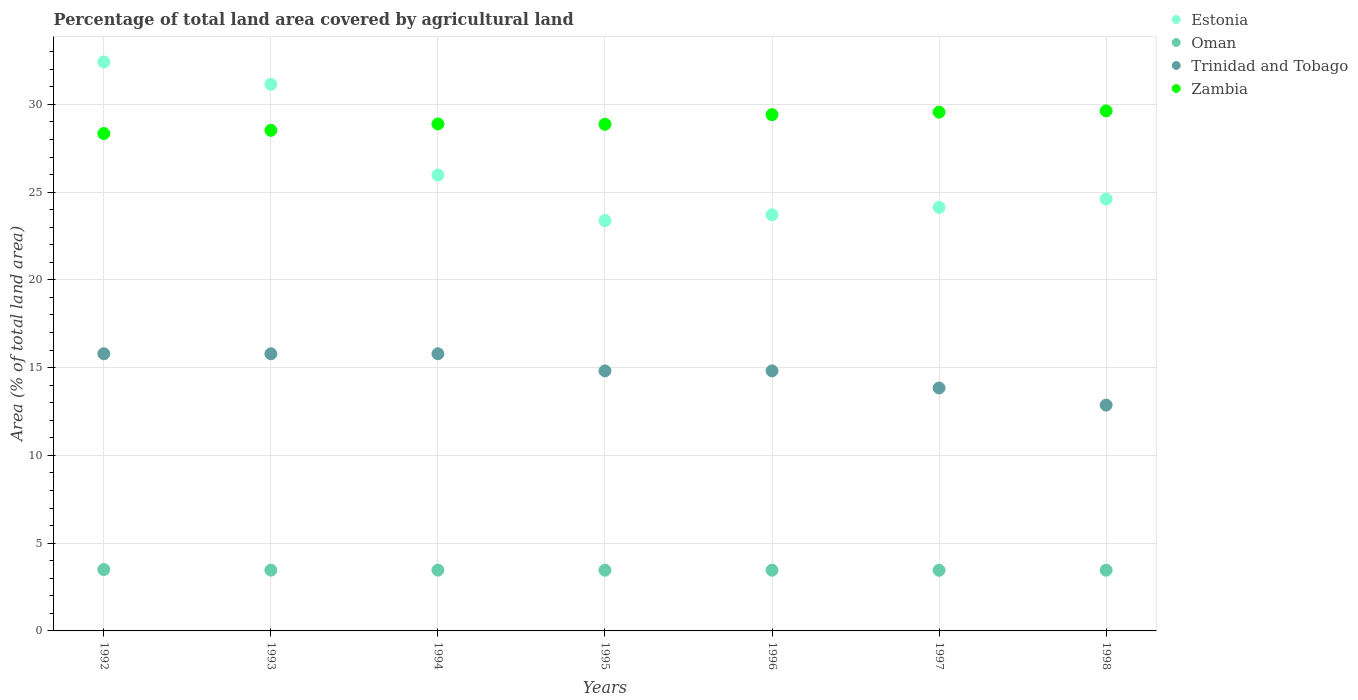What is the percentage of agricultural land in Estonia in 1996?
Ensure brevity in your answer.  23.71. Across all years, what is the maximum percentage of agricultural land in Zambia?
Your answer should be compact. 29.63. Across all years, what is the minimum percentage of agricultural land in Trinidad and Tobago?
Your answer should be very brief. 12.87. In which year was the percentage of agricultural land in Trinidad and Tobago maximum?
Provide a short and direct response. 1992. What is the total percentage of agricultural land in Trinidad and Tobago in the graph?
Provide a succinct answer. 103.7. What is the difference between the percentage of agricultural land in Oman in 1992 and that in 1996?
Provide a succinct answer. 0.04. What is the difference between the percentage of agricultural land in Trinidad and Tobago in 1992 and the percentage of agricultural land in Oman in 1995?
Your response must be concise. 12.33. What is the average percentage of agricultural land in Estonia per year?
Your response must be concise. 26.48. In the year 1995, what is the difference between the percentage of agricultural land in Oman and percentage of agricultural land in Zambia?
Offer a terse response. -25.4. What is the ratio of the percentage of agricultural land in Oman in 1995 to that in 1996?
Make the answer very short. 1. What is the difference between the highest and the second highest percentage of agricultural land in Zambia?
Give a very brief answer. 0.07. What is the difference between the highest and the lowest percentage of agricultural land in Zambia?
Your response must be concise. 1.29. Is it the case that in every year, the sum of the percentage of agricultural land in Estonia and percentage of agricultural land in Oman  is greater than the sum of percentage of agricultural land in Zambia and percentage of agricultural land in Trinidad and Tobago?
Give a very brief answer. No. Is it the case that in every year, the sum of the percentage of agricultural land in Estonia and percentage of agricultural land in Zambia  is greater than the percentage of agricultural land in Trinidad and Tobago?
Provide a short and direct response. Yes. Is the percentage of agricultural land in Zambia strictly less than the percentage of agricultural land in Trinidad and Tobago over the years?
Your answer should be very brief. No. How many dotlines are there?
Offer a terse response. 4. How many years are there in the graph?
Provide a succinct answer. 7. What is the difference between two consecutive major ticks on the Y-axis?
Offer a very short reply. 5. Are the values on the major ticks of Y-axis written in scientific E-notation?
Offer a terse response. No. Does the graph contain grids?
Offer a very short reply. Yes. Where does the legend appear in the graph?
Keep it short and to the point. Top right. How many legend labels are there?
Offer a very short reply. 4. How are the legend labels stacked?
Offer a terse response. Vertical. What is the title of the graph?
Provide a short and direct response. Percentage of total land area covered by agricultural land. What is the label or title of the Y-axis?
Provide a short and direct response. Area (% of total land area). What is the Area (% of total land area) of Estonia in 1992?
Make the answer very short. 32.41. What is the Area (% of total land area) of Oman in 1992?
Ensure brevity in your answer.  3.5. What is the Area (% of total land area) in Trinidad and Tobago in 1992?
Keep it short and to the point. 15.79. What is the Area (% of total land area) of Zambia in 1992?
Keep it short and to the point. 28.34. What is the Area (% of total land area) in Estonia in 1993?
Your answer should be compact. 31.14. What is the Area (% of total land area) of Oman in 1993?
Your answer should be compact. 3.46. What is the Area (% of total land area) of Trinidad and Tobago in 1993?
Keep it short and to the point. 15.79. What is the Area (% of total land area) in Zambia in 1993?
Your answer should be very brief. 28.52. What is the Area (% of total land area) of Estonia in 1994?
Keep it short and to the point. 25.97. What is the Area (% of total land area) in Oman in 1994?
Your response must be concise. 3.46. What is the Area (% of total land area) of Trinidad and Tobago in 1994?
Offer a very short reply. 15.79. What is the Area (% of total land area) in Zambia in 1994?
Make the answer very short. 28.89. What is the Area (% of total land area) in Estonia in 1995?
Ensure brevity in your answer.  23.38. What is the Area (% of total land area) in Oman in 1995?
Provide a succinct answer. 3.46. What is the Area (% of total land area) in Trinidad and Tobago in 1995?
Provide a succinct answer. 14.81. What is the Area (% of total land area) in Zambia in 1995?
Provide a succinct answer. 28.87. What is the Area (% of total land area) of Estonia in 1996?
Keep it short and to the point. 23.71. What is the Area (% of total land area) of Oman in 1996?
Your answer should be very brief. 3.46. What is the Area (% of total land area) of Trinidad and Tobago in 1996?
Keep it short and to the point. 14.81. What is the Area (% of total land area) of Zambia in 1996?
Your response must be concise. 29.41. What is the Area (% of total land area) in Estonia in 1997?
Offer a very short reply. 24.13. What is the Area (% of total land area) of Oman in 1997?
Provide a succinct answer. 3.46. What is the Area (% of total land area) in Trinidad and Tobago in 1997?
Your response must be concise. 13.84. What is the Area (% of total land area) in Zambia in 1997?
Keep it short and to the point. 29.56. What is the Area (% of total land area) of Estonia in 1998?
Give a very brief answer. 24.6. What is the Area (% of total land area) of Oman in 1998?
Provide a short and direct response. 3.46. What is the Area (% of total land area) in Trinidad and Tobago in 1998?
Provide a short and direct response. 12.87. What is the Area (% of total land area) of Zambia in 1998?
Keep it short and to the point. 29.63. Across all years, what is the maximum Area (% of total land area) in Estonia?
Provide a succinct answer. 32.41. Across all years, what is the maximum Area (% of total land area) in Oman?
Give a very brief answer. 3.5. Across all years, what is the maximum Area (% of total land area) in Trinidad and Tobago?
Provide a succinct answer. 15.79. Across all years, what is the maximum Area (% of total land area) in Zambia?
Your answer should be very brief. 29.63. Across all years, what is the minimum Area (% of total land area) of Estonia?
Provide a short and direct response. 23.38. Across all years, what is the minimum Area (% of total land area) in Oman?
Give a very brief answer. 3.46. Across all years, what is the minimum Area (% of total land area) of Trinidad and Tobago?
Offer a terse response. 12.87. Across all years, what is the minimum Area (% of total land area) of Zambia?
Your answer should be compact. 28.34. What is the total Area (% of total land area) in Estonia in the graph?
Make the answer very short. 185.35. What is the total Area (% of total land area) of Oman in the graph?
Offer a terse response. 24.26. What is the total Area (% of total land area) in Trinidad and Tobago in the graph?
Provide a short and direct response. 103.7. What is the total Area (% of total land area) of Zambia in the graph?
Provide a short and direct response. 203.2. What is the difference between the Area (% of total land area) of Estonia in 1992 and that in 1993?
Make the answer very short. 1.27. What is the difference between the Area (% of total land area) of Oman in 1992 and that in 1993?
Your answer should be compact. 0.04. What is the difference between the Area (% of total land area) in Zambia in 1992 and that in 1993?
Offer a very short reply. -0.18. What is the difference between the Area (% of total land area) in Estonia in 1992 and that in 1994?
Keep it short and to the point. 6.44. What is the difference between the Area (% of total land area) in Oman in 1992 and that in 1994?
Provide a short and direct response. 0.04. What is the difference between the Area (% of total land area) of Zambia in 1992 and that in 1994?
Provide a short and direct response. -0.55. What is the difference between the Area (% of total land area) in Estonia in 1992 and that in 1995?
Offer a very short reply. 9.04. What is the difference between the Area (% of total land area) of Oman in 1992 and that in 1995?
Your answer should be compact. 0.04. What is the difference between the Area (% of total land area) in Trinidad and Tobago in 1992 and that in 1995?
Keep it short and to the point. 0.97. What is the difference between the Area (% of total land area) in Zambia in 1992 and that in 1995?
Offer a very short reply. -0.53. What is the difference between the Area (% of total land area) in Estonia in 1992 and that in 1996?
Keep it short and to the point. 8.7. What is the difference between the Area (% of total land area) of Oman in 1992 and that in 1996?
Your answer should be very brief. 0.04. What is the difference between the Area (% of total land area) in Trinidad and Tobago in 1992 and that in 1996?
Give a very brief answer. 0.97. What is the difference between the Area (% of total land area) in Zambia in 1992 and that in 1996?
Provide a succinct answer. -1.08. What is the difference between the Area (% of total land area) in Estonia in 1992 and that in 1997?
Offer a terse response. 8.28. What is the difference between the Area (% of total land area) of Oman in 1992 and that in 1997?
Ensure brevity in your answer.  0.04. What is the difference between the Area (% of total land area) in Trinidad and Tobago in 1992 and that in 1997?
Provide a short and direct response. 1.95. What is the difference between the Area (% of total land area) of Zambia in 1992 and that in 1997?
Provide a succinct answer. -1.22. What is the difference between the Area (% of total land area) of Estonia in 1992 and that in 1998?
Make the answer very short. 7.81. What is the difference between the Area (% of total land area) of Oman in 1992 and that in 1998?
Provide a succinct answer. 0.04. What is the difference between the Area (% of total land area) of Trinidad and Tobago in 1992 and that in 1998?
Make the answer very short. 2.92. What is the difference between the Area (% of total land area) of Zambia in 1992 and that in 1998?
Provide a succinct answer. -1.29. What is the difference between the Area (% of total land area) of Estonia in 1993 and that in 1994?
Your answer should be compact. 5.17. What is the difference between the Area (% of total land area) in Oman in 1993 and that in 1994?
Offer a very short reply. 0. What is the difference between the Area (% of total land area) in Zambia in 1993 and that in 1994?
Provide a short and direct response. -0.36. What is the difference between the Area (% of total land area) of Estonia in 1993 and that in 1995?
Provide a short and direct response. 7.76. What is the difference between the Area (% of total land area) of Oman in 1993 and that in 1995?
Provide a succinct answer. 0. What is the difference between the Area (% of total land area) of Trinidad and Tobago in 1993 and that in 1995?
Keep it short and to the point. 0.97. What is the difference between the Area (% of total land area) of Zambia in 1993 and that in 1995?
Give a very brief answer. -0.34. What is the difference between the Area (% of total land area) in Estonia in 1993 and that in 1996?
Give a very brief answer. 7.43. What is the difference between the Area (% of total land area) of Oman in 1993 and that in 1996?
Offer a very short reply. 0. What is the difference between the Area (% of total land area) in Trinidad and Tobago in 1993 and that in 1996?
Give a very brief answer. 0.97. What is the difference between the Area (% of total land area) of Zambia in 1993 and that in 1996?
Provide a succinct answer. -0.89. What is the difference between the Area (% of total land area) in Estonia in 1993 and that in 1997?
Give a very brief answer. 7.01. What is the difference between the Area (% of total land area) of Oman in 1993 and that in 1997?
Give a very brief answer. 0.01. What is the difference between the Area (% of total land area) of Trinidad and Tobago in 1993 and that in 1997?
Keep it short and to the point. 1.95. What is the difference between the Area (% of total land area) in Zambia in 1993 and that in 1997?
Your answer should be very brief. -1.03. What is the difference between the Area (% of total land area) of Estonia in 1993 and that in 1998?
Make the answer very short. 6.53. What is the difference between the Area (% of total land area) in Oman in 1993 and that in 1998?
Provide a succinct answer. 0. What is the difference between the Area (% of total land area) of Trinidad and Tobago in 1993 and that in 1998?
Ensure brevity in your answer.  2.92. What is the difference between the Area (% of total land area) in Zambia in 1993 and that in 1998?
Your answer should be compact. -1.11. What is the difference between the Area (% of total land area) in Estonia in 1994 and that in 1995?
Make the answer very short. 2.6. What is the difference between the Area (% of total land area) of Oman in 1994 and that in 1995?
Give a very brief answer. 0. What is the difference between the Area (% of total land area) in Trinidad and Tobago in 1994 and that in 1995?
Make the answer very short. 0.97. What is the difference between the Area (% of total land area) of Zambia in 1994 and that in 1995?
Your response must be concise. 0.02. What is the difference between the Area (% of total land area) in Estonia in 1994 and that in 1996?
Make the answer very short. 2.26. What is the difference between the Area (% of total land area) of Oman in 1994 and that in 1996?
Ensure brevity in your answer.  0. What is the difference between the Area (% of total land area) of Trinidad and Tobago in 1994 and that in 1996?
Provide a short and direct response. 0.97. What is the difference between the Area (% of total land area) of Zambia in 1994 and that in 1996?
Provide a short and direct response. -0.53. What is the difference between the Area (% of total land area) of Estonia in 1994 and that in 1997?
Provide a short and direct response. 1.84. What is the difference between the Area (% of total land area) of Oman in 1994 and that in 1997?
Give a very brief answer. 0.01. What is the difference between the Area (% of total land area) in Trinidad and Tobago in 1994 and that in 1997?
Your answer should be very brief. 1.95. What is the difference between the Area (% of total land area) in Zambia in 1994 and that in 1997?
Ensure brevity in your answer.  -0.67. What is the difference between the Area (% of total land area) in Estonia in 1994 and that in 1998?
Give a very brief answer. 1.37. What is the difference between the Area (% of total land area) in Oman in 1994 and that in 1998?
Keep it short and to the point. 0. What is the difference between the Area (% of total land area) of Trinidad and Tobago in 1994 and that in 1998?
Your answer should be compact. 2.92. What is the difference between the Area (% of total land area) of Zambia in 1994 and that in 1998?
Provide a short and direct response. -0.74. What is the difference between the Area (% of total land area) in Estonia in 1995 and that in 1996?
Your answer should be very brief. -0.33. What is the difference between the Area (% of total land area) of Oman in 1995 and that in 1996?
Give a very brief answer. 0. What is the difference between the Area (% of total land area) of Trinidad and Tobago in 1995 and that in 1996?
Make the answer very short. 0. What is the difference between the Area (% of total land area) in Zambia in 1995 and that in 1996?
Offer a terse response. -0.55. What is the difference between the Area (% of total land area) of Estonia in 1995 and that in 1997?
Give a very brief answer. -0.75. What is the difference between the Area (% of total land area) in Oman in 1995 and that in 1997?
Ensure brevity in your answer.  0. What is the difference between the Area (% of total land area) of Trinidad and Tobago in 1995 and that in 1997?
Your response must be concise. 0.97. What is the difference between the Area (% of total land area) in Zambia in 1995 and that in 1997?
Ensure brevity in your answer.  -0.69. What is the difference between the Area (% of total land area) of Estonia in 1995 and that in 1998?
Ensure brevity in your answer.  -1.23. What is the difference between the Area (% of total land area) of Oman in 1995 and that in 1998?
Your response must be concise. 0. What is the difference between the Area (% of total land area) in Trinidad and Tobago in 1995 and that in 1998?
Offer a terse response. 1.95. What is the difference between the Area (% of total land area) of Zambia in 1995 and that in 1998?
Offer a very short reply. -0.76. What is the difference between the Area (% of total land area) in Estonia in 1996 and that in 1997?
Your answer should be very brief. -0.42. What is the difference between the Area (% of total land area) in Oman in 1996 and that in 1997?
Your answer should be compact. 0. What is the difference between the Area (% of total land area) in Trinidad and Tobago in 1996 and that in 1997?
Provide a short and direct response. 0.97. What is the difference between the Area (% of total land area) in Zambia in 1996 and that in 1997?
Ensure brevity in your answer.  -0.14. What is the difference between the Area (% of total land area) of Estonia in 1996 and that in 1998?
Offer a very short reply. -0.9. What is the difference between the Area (% of total land area) in Trinidad and Tobago in 1996 and that in 1998?
Provide a short and direct response. 1.95. What is the difference between the Area (% of total land area) of Zambia in 1996 and that in 1998?
Make the answer very short. -0.22. What is the difference between the Area (% of total land area) of Estonia in 1997 and that in 1998?
Offer a terse response. -0.47. What is the difference between the Area (% of total land area) of Oman in 1997 and that in 1998?
Offer a terse response. -0. What is the difference between the Area (% of total land area) in Trinidad and Tobago in 1997 and that in 1998?
Make the answer very short. 0.97. What is the difference between the Area (% of total land area) of Zambia in 1997 and that in 1998?
Offer a terse response. -0.07. What is the difference between the Area (% of total land area) of Estonia in 1992 and the Area (% of total land area) of Oman in 1993?
Provide a short and direct response. 28.95. What is the difference between the Area (% of total land area) in Estonia in 1992 and the Area (% of total land area) in Trinidad and Tobago in 1993?
Provide a succinct answer. 16.62. What is the difference between the Area (% of total land area) in Estonia in 1992 and the Area (% of total land area) in Zambia in 1993?
Provide a succinct answer. 3.89. What is the difference between the Area (% of total land area) of Oman in 1992 and the Area (% of total land area) of Trinidad and Tobago in 1993?
Ensure brevity in your answer.  -12.29. What is the difference between the Area (% of total land area) in Oman in 1992 and the Area (% of total land area) in Zambia in 1993?
Offer a terse response. -25.02. What is the difference between the Area (% of total land area) of Trinidad and Tobago in 1992 and the Area (% of total land area) of Zambia in 1993?
Ensure brevity in your answer.  -12.73. What is the difference between the Area (% of total land area) of Estonia in 1992 and the Area (% of total land area) of Oman in 1994?
Offer a terse response. 28.95. What is the difference between the Area (% of total land area) of Estonia in 1992 and the Area (% of total land area) of Trinidad and Tobago in 1994?
Offer a very short reply. 16.62. What is the difference between the Area (% of total land area) of Estonia in 1992 and the Area (% of total land area) of Zambia in 1994?
Keep it short and to the point. 3.53. What is the difference between the Area (% of total land area) of Oman in 1992 and the Area (% of total land area) of Trinidad and Tobago in 1994?
Provide a succinct answer. -12.29. What is the difference between the Area (% of total land area) of Oman in 1992 and the Area (% of total land area) of Zambia in 1994?
Provide a succinct answer. -25.39. What is the difference between the Area (% of total land area) in Trinidad and Tobago in 1992 and the Area (% of total land area) in Zambia in 1994?
Provide a succinct answer. -13.1. What is the difference between the Area (% of total land area) of Estonia in 1992 and the Area (% of total land area) of Oman in 1995?
Ensure brevity in your answer.  28.95. What is the difference between the Area (% of total land area) of Estonia in 1992 and the Area (% of total land area) of Trinidad and Tobago in 1995?
Provide a succinct answer. 17.6. What is the difference between the Area (% of total land area) in Estonia in 1992 and the Area (% of total land area) in Zambia in 1995?
Offer a terse response. 3.55. What is the difference between the Area (% of total land area) of Oman in 1992 and the Area (% of total land area) of Trinidad and Tobago in 1995?
Offer a terse response. -11.32. What is the difference between the Area (% of total land area) in Oman in 1992 and the Area (% of total land area) in Zambia in 1995?
Provide a short and direct response. -25.37. What is the difference between the Area (% of total land area) of Trinidad and Tobago in 1992 and the Area (% of total land area) of Zambia in 1995?
Ensure brevity in your answer.  -13.08. What is the difference between the Area (% of total land area) of Estonia in 1992 and the Area (% of total land area) of Oman in 1996?
Your answer should be compact. 28.95. What is the difference between the Area (% of total land area) of Estonia in 1992 and the Area (% of total land area) of Trinidad and Tobago in 1996?
Give a very brief answer. 17.6. What is the difference between the Area (% of total land area) of Estonia in 1992 and the Area (% of total land area) of Zambia in 1996?
Make the answer very short. 3. What is the difference between the Area (% of total land area) of Oman in 1992 and the Area (% of total land area) of Trinidad and Tobago in 1996?
Keep it short and to the point. -11.32. What is the difference between the Area (% of total land area) in Oman in 1992 and the Area (% of total land area) in Zambia in 1996?
Give a very brief answer. -25.91. What is the difference between the Area (% of total land area) of Trinidad and Tobago in 1992 and the Area (% of total land area) of Zambia in 1996?
Offer a terse response. -13.62. What is the difference between the Area (% of total land area) of Estonia in 1992 and the Area (% of total land area) of Oman in 1997?
Keep it short and to the point. 28.96. What is the difference between the Area (% of total land area) of Estonia in 1992 and the Area (% of total land area) of Trinidad and Tobago in 1997?
Ensure brevity in your answer.  18.57. What is the difference between the Area (% of total land area) of Estonia in 1992 and the Area (% of total land area) of Zambia in 1997?
Ensure brevity in your answer.  2.86. What is the difference between the Area (% of total land area) of Oman in 1992 and the Area (% of total land area) of Trinidad and Tobago in 1997?
Your answer should be very brief. -10.34. What is the difference between the Area (% of total land area) of Oman in 1992 and the Area (% of total land area) of Zambia in 1997?
Offer a terse response. -26.06. What is the difference between the Area (% of total land area) in Trinidad and Tobago in 1992 and the Area (% of total land area) in Zambia in 1997?
Make the answer very short. -13.77. What is the difference between the Area (% of total land area) of Estonia in 1992 and the Area (% of total land area) of Oman in 1998?
Your response must be concise. 28.95. What is the difference between the Area (% of total land area) of Estonia in 1992 and the Area (% of total land area) of Trinidad and Tobago in 1998?
Your response must be concise. 19.55. What is the difference between the Area (% of total land area) of Estonia in 1992 and the Area (% of total land area) of Zambia in 1998?
Your response must be concise. 2.79. What is the difference between the Area (% of total land area) of Oman in 1992 and the Area (% of total land area) of Trinidad and Tobago in 1998?
Provide a succinct answer. -9.37. What is the difference between the Area (% of total land area) in Oman in 1992 and the Area (% of total land area) in Zambia in 1998?
Give a very brief answer. -26.13. What is the difference between the Area (% of total land area) of Trinidad and Tobago in 1992 and the Area (% of total land area) of Zambia in 1998?
Your answer should be very brief. -13.84. What is the difference between the Area (% of total land area) in Estonia in 1993 and the Area (% of total land area) in Oman in 1994?
Offer a terse response. 27.68. What is the difference between the Area (% of total land area) of Estonia in 1993 and the Area (% of total land area) of Trinidad and Tobago in 1994?
Make the answer very short. 15.35. What is the difference between the Area (% of total land area) of Estonia in 1993 and the Area (% of total land area) of Zambia in 1994?
Give a very brief answer. 2.25. What is the difference between the Area (% of total land area) in Oman in 1993 and the Area (% of total land area) in Trinidad and Tobago in 1994?
Make the answer very short. -12.33. What is the difference between the Area (% of total land area) in Oman in 1993 and the Area (% of total land area) in Zambia in 1994?
Your answer should be very brief. -25.42. What is the difference between the Area (% of total land area) in Trinidad and Tobago in 1993 and the Area (% of total land area) in Zambia in 1994?
Keep it short and to the point. -13.1. What is the difference between the Area (% of total land area) of Estonia in 1993 and the Area (% of total land area) of Oman in 1995?
Make the answer very short. 27.68. What is the difference between the Area (% of total land area) of Estonia in 1993 and the Area (% of total land area) of Trinidad and Tobago in 1995?
Your answer should be very brief. 16.32. What is the difference between the Area (% of total land area) of Estonia in 1993 and the Area (% of total land area) of Zambia in 1995?
Offer a terse response. 2.27. What is the difference between the Area (% of total land area) in Oman in 1993 and the Area (% of total land area) in Trinidad and Tobago in 1995?
Keep it short and to the point. -11.35. What is the difference between the Area (% of total land area) in Oman in 1993 and the Area (% of total land area) in Zambia in 1995?
Offer a very short reply. -25.4. What is the difference between the Area (% of total land area) of Trinidad and Tobago in 1993 and the Area (% of total land area) of Zambia in 1995?
Your answer should be very brief. -13.08. What is the difference between the Area (% of total land area) in Estonia in 1993 and the Area (% of total land area) in Oman in 1996?
Keep it short and to the point. 27.68. What is the difference between the Area (% of total land area) in Estonia in 1993 and the Area (% of total land area) in Trinidad and Tobago in 1996?
Give a very brief answer. 16.32. What is the difference between the Area (% of total land area) of Estonia in 1993 and the Area (% of total land area) of Zambia in 1996?
Your answer should be very brief. 1.73. What is the difference between the Area (% of total land area) in Oman in 1993 and the Area (% of total land area) in Trinidad and Tobago in 1996?
Provide a succinct answer. -11.35. What is the difference between the Area (% of total land area) in Oman in 1993 and the Area (% of total land area) in Zambia in 1996?
Provide a short and direct response. -25.95. What is the difference between the Area (% of total land area) of Trinidad and Tobago in 1993 and the Area (% of total land area) of Zambia in 1996?
Provide a short and direct response. -13.62. What is the difference between the Area (% of total land area) of Estonia in 1993 and the Area (% of total land area) of Oman in 1997?
Give a very brief answer. 27.68. What is the difference between the Area (% of total land area) of Estonia in 1993 and the Area (% of total land area) of Trinidad and Tobago in 1997?
Provide a succinct answer. 17.3. What is the difference between the Area (% of total land area) of Estonia in 1993 and the Area (% of total land area) of Zambia in 1997?
Your answer should be compact. 1.58. What is the difference between the Area (% of total land area) of Oman in 1993 and the Area (% of total land area) of Trinidad and Tobago in 1997?
Give a very brief answer. -10.38. What is the difference between the Area (% of total land area) of Oman in 1993 and the Area (% of total land area) of Zambia in 1997?
Offer a terse response. -26.09. What is the difference between the Area (% of total land area) in Trinidad and Tobago in 1993 and the Area (% of total land area) in Zambia in 1997?
Your response must be concise. -13.77. What is the difference between the Area (% of total land area) of Estonia in 1993 and the Area (% of total land area) of Oman in 1998?
Ensure brevity in your answer.  27.68. What is the difference between the Area (% of total land area) of Estonia in 1993 and the Area (% of total land area) of Trinidad and Tobago in 1998?
Your response must be concise. 18.27. What is the difference between the Area (% of total land area) of Estonia in 1993 and the Area (% of total land area) of Zambia in 1998?
Your response must be concise. 1.51. What is the difference between the Area (% of total land area) of Oman in 1993 and the Area (% of total land area) of Trinidad and Tobago in 1998?
Provide a succinct answer. -9.4. What is the difference between the Area (% of total land area) in Oman in 1993 and the Area (% of total land area) in Zambia in 1998?
Offer a terse response. -26.16. What is the difference between the Area (% of total land area) of Trinidad and Tobago in 1993 and the Area (% of total land area) of Zambia in 1998?
Your answer should be compact. -13.84. What is the difference between the Area (% of total land area) in Estonia in 1994 and the Area (% of total land area) in Oman in 1995?
Give a very brief answer. 22.51. What is the difference between the Area (% of total land area) of Estonia in 1994 and the Area (% of total land area) of Trinidad and Tobago in 1995?
Your response must be concise. 11.16. What is the difference between the Area (% of total land area) in Estonia in 1994 and the Area (% of total land area) in Zambia in 1995?
Keep it short and to the point. -2.89. What is the difference between the Area (% of total land area) of Oman in 1994 and the Area (% of total land area) of Trinidad and Tobago in 1995?
Provide a short and direct response. -11.35. What is the difference between the Area (% of total land area) of Oman in 1994 and the Area (% of total land area) of Zambia in 1995?
Offer a terse response. -25.4. What is the difference between the Area (% of total land area) of Trinidad and Tobago in 1994 and the Area (% of total land area) of Zambia in 1995?
Ensure brevity in your answer.  -13.08. What is the difference between the Area (% of total land area) in Estonia in 1994 and the Area (% of total land area) in Oman in 1996?
Provide a short and direct response. 22.51. What is the difference between the Area (% of total land area) of Estonia in 1994 and the Area (% of total land area) of Trinidad and Tobago in 1996?
Your answer should be compact. 11.16. What is the difference between the Area (% of total land area) of Estonia in 1994 and the Area (% of total land area) of Zambia in 1996?
Provide a short and direct response. -3.44. What is the difference between the Area (% of total land area) in Oman in 1994 and the Area (% of total land area) in Trinidad and Tobago in 1996?
Provide a short and direct response. -11.35. What is the difference between the Area (% of total land area) in Oman in 1994 and the Area (% of total land area) in Zambia in 1996?
Give a very brief answer. -25.95. What is the difference between the Area (% of total land area) in Trinidad and Tobago in 1994 and the Area (% of total land area) in Zambia in 1996?
Keep it short and to the point. -13.62. What is the difference between the Area (% of total land area) in Estonia in 1994 and the Area (% of total land area) in Oman in 1997?
Keep it short and to the point. 22.52. What is the difference between the Area (% of total land area) of Estonia in 1994 and the Area (% of total land area) of Trinidad and Tobago in 1997?
Your answer should be very brief. 12.13. What is the difference between the Area (% of total land area) in Estonia in 1994 and the Area (% of total land area) in Zambia in 1997?
Keep it short and to the point. -3.58. What is the difference between the Area (% of total land area) of Oman in 1994 and the Area (% of total land area) of Trinidad and Tobago in 1997?
Provide a short and direct response. -10.38. What is the difference between the Area (% of total land area) of Oman in 1994 and the Area (% of total land area) of Zambia in 1997?
Keep it short and to the point. -26.09. What is the difference between the Area (% of total land area) in Trinidad and Tobago in 1994 and the Area (% of total land area) in Zambia in 1997?
Make the answer very short. -13.77. What is the difference between the Area (% of total land area) of Estonia in 1994 and the Area (% of total land area) of Oman in 1998?
Your answer should be very brief. 22.51. What is the difference between the Area (% of total land area) in Estonia in 1994 and the Area (% of total land area) in Trinidad and Tobago in 1998?
Your answer should be very brief. 13.11. What is the difference between the Area (% of total land area) of Estonia in 1994 and the Area (% of total land area) of Zambia in 1998?
Ensure brevity in your answer.  -3.65. What is the difference between the Area (% of total land area) of Oman in 1994 and the Area (% of total land area) of Trinidad and Tobago in 1998?
Make the answer very short. -9.4. What is the difference between the Area (% of total land area) of Oman in 1994 and the Area (% of total land area) of Zambia in 1998?
Provide a short and direct response. -26.16. What is the difference between the Area (% of total land area) in Trinidad and Tobago in 1994 and the Area (% of total land area) in Zambia in 1998?
Your answer should be very brief. -13.84. What is the difference between the Area (% of total land area) in Estonia in 1995 and the Area (% of total land area) in Oman in 1996?
Offer a very short reply. 19.92. What is the difference between the Area (% of total land area) of Estonia in 1995 and the Area (% of total land area) of Trinidad and Tobago in 1996?
Provide a short and direct response. 8.56. What is the difference between the Area (% of total land area) in Estonia in 1995 and the Area (% of total land area) in Zambia in 1996?
Provide a succinct answer. -6.03. What is the difference between the Area (% of total land area) of Oman in 1995 and the Area (% of total land area) of Trinidad and Tobago in 1996?
Ensure brevity in your answer.  -11.35. What is the difference between the Area (% of total land area) in Oman in 1995 and the Area (% of total land area) in Zambia in 1996?
Your answer should be compact. -25.95. What is the difference between the Area (% of total land area) in Trinidad and Tobago in 1995 and the Area (% of total land area) in Zambia in 1996?
Your answer should be very brief. -14.6. What is the difference between the Area (% of total land area) in Estonia in 1995 and the Area (% of total land area) in Oman in 1997?
Make the answer very short. 19.92. What is the difference between the Area (% of total land area) of Estonia in 1995 and the Area (% of total land area) of Trinidad and Tobago in 1997?
Ensure brevity in your answer.  9.54. What is the difference between the Area (% of total land area) in Estonia in 1995 and the Area (% of total land area) in Zambia in 1997?
Your response must be concise. -6.18. What is the difference between the Area (% of total land area) in Oman in 1995 and the Area (% of total land area) in Trinidad and Tobago in 1997?
Keep it short and to the point. -10.38. What is the difference between the Area (% of total land area) of Oman in 1995 and the Area (% of total land area) of Zambia in 1997?
Provide a short and direct response. -26.09. What is the difference between the Area (% of total land area) of Trinidad and Tobago in 1995 and the Area (% of total land area) of Zambia in 1997?
Your answer should be compact. -14.74. What is the difference between the Area (% of total land area) in Estonia in 1995 and the Area (% of total land area) in Oman in 1998?
Give a very brief answer. 19.92. What is the difference between the Area (% of total land area) in Estonia in 1995 and the Area (% of total land area) in Trinidad and Tobago in 1998?
Offer a terse response. 10.51. What is the difference between the Area (% of total land area) in Estonia in 1995 and the Area (% of total land area) in Zambia in 1998?
Your answer should be very brief. -6.25. What is the difference between the Area (% of total land area) of Oman in 1995 and the Area (% of total land area) of Trinidad and Tobago in 1998?
Ensure brevity in your answer.  -9.41. What is the difference between the Area (% of total land area) in Oman in 1995 and the Area (% of total land area) in Zambia in 1998?
Provide a short and direct response. -26.17. What is the difference between the Area (% of total land area) of Trinidad and Tobago in 1995 and the Area (% of total land area) of Zambia in 1998?
Make the answer very short. -14.81. What is the difference between the Area (% of total land area) of Estonia in 1996 and the Area (% of total land area) of Oman in 1997?
Make the answer very short. 20.25. What is the difference between the Area (% of total land area) in Estonia in 1996 and the Area (% of total land area) in Trinidad and Tobago in 1997?
Your answer should be very brief. 9.87. What is the difference between the Area (% of total land area) of Estonia in 1996 and the Area (% of total land area) of Zambia in 1997?
Keep it short and to the point. -5.85. What is the difference between the Area (% of total land area) in Oman in 1996 and the Area (% of total land area) in Trinidad and Tobago in 1997?
Offer a terse response. -10.38. What is the difference between the Area (% of total land area) in Oman in 1996 and the Area (% of total land area) in Zambia in 1997?
Your response must be concise. -26.09. What is the difference between the Area (% of total land area) in Trinidad and Tobago in 1996 and the Area (% of total land area) in Zambia in 1997?
Keep it short and to the point. -14.74. What is the difference between the Area (% of total land area) of Estonia in 1996 and the Area (% of total land area) of Oman in 1998?
Offer a terse response. 20.25. What is the difference between the Area (% of total land area) of Estonia in 1996 and the Area (% of total land area) of Trinidad and Tobago in 1998?
Make the answer very short. 10.84. What is the difference between the Area (% of total land area) of Estonia in 1996 and the Area (% of total land area) of Zambia in 1998?
Offer a very short reply. -5.92. What is the difference between the Area (% of total land area) of Oman in 1996 and the Area (% of total land area) of Trinidad and Tobago in 1998?
Ensure brevity in your answer.  -9.41. What is the difference between the Area (% of total land area) in Oman in 1996 and the Area (% of total land area) in Zambia in 1998?
Keep it short and to the point. -26.17. What is the difference between the Area (% of total land area) of Trinidad and Tobago in 1996 and the Area (% of total land area) of Zambia in 1998?
Make the answer very short. -14.81. What is the difference between the Area (% of total land area) in Estonia in 1997 and the Area (% of total land area) in Oman in 1998?
Offer a very short reply. 20.67. What is the difference between the Area (% of total land area) of Estonia in 1997 and the Area (% of total land area) of Trinidad and Tobago in 1998?
Provide a short and direct response. 11.27. What is the difference between the Area (% of total land area) of Estonia in 1997 and the Area (% of total land area) of Zambia in 1998?
Ensure brevity in your answer.  -5.49. What is the difference between the Area (% of total land area) of Oman in 1997 and the Area (% of total land area) of Trinidad and Tobago in 1998?
Your response must be concise. -9.41. What is the difference between the Area (% of total land area) of Oman in 1997 and the Area (% of total land area) of Zambia in 1998?
Provide a succinct answer. -26.17. What is the difference between the Area (% of total land area) in Trinidad and Tobago in 1997 and the Area (% of total land area) in Zambia in 1998?
Give a very brief answer. -15.79. What is the average Area (% of total land area) of Estonia per year?
Make the answer very short. 26.48. What is the average Area (% of total land area) in Oman per year?
Provide a short and direct response. 3.47. What is the average Area (% of total land area) in Trinidad and Tobago per year?
Provide a short and direct response. 14.81. What is the average Area (% of total land area) in Zambia per year?
Offer a very short reply. 29.03. In the year 1992, what is the difference between the Area (% of total land area) of Estonia and Area (% of total land area) of Oman?
Your answer should be compact. 28.91. In the year 1992, what is the difference between the Area (% of total land area) of Estonia and Area (% of total land area) of Trinidad and Tobago?
Offer a terse response. 16.62. In the year 1992, what is the difference between the Area (% of total land area) of Estonia and Area (% of total land area) of Zambia?
Provide a succinct answer. 4.08. In the year 1992, what is the difference between the Area (% of total land area) of Oman and Area (% of total land area) of Trinidad and Tobago?
Offer a terse response. -12.29. In the year 1992, what is the difference between the Area (% of total land area) of Oman and Area (% of total land area) of Zambia?
Your answer should be compact. -24.84. In the year 1992, what is the difference between the Area (% of total land area) of Trinidad and Tobago and Area (% of total land area) of Zambia?
Ensure brevity in your answer.  -12.55. In the year 1993, what is the difference between the Area (% of total land area) in Estonia and Area (% of total land area) in Oman?
Give a very brief answer. 27.68. In the year 1993, what is the difference between the Area (% of total land area) of Estonia and Area (% of total land area) of Trinidad and Tobago?
Offer a very short reply. 15.35. In the year 1993, what is the difference between the Area (% of total land area) in Estonia and Area (% of total land area) in Zambia?
Offer a terse response. 2.62. In the year 1993, what is the difference between the Area (% of total land area) of Oman and Area (% of total land area) of Trinidad and Tobago?
Make the answer very short. -12.33. In the year 1993, what is the difference between the Area (% of total land area) in Oman and Area (% of total land area) in Zambia?
Ensure brevity in your answer.  -25.06. In the year 1993, what is the difference between the Area (% of total land area) in Trinidad and Tobago and Area (% of total land area) in Zambia?
Keep it short and to the point. -12.73. In the year 1994, what is the difference between the Area (% of total land area) of Estonia and Area (% of total land area) of Oman?
Offer a terse response. 22.51. In the year 1994, what is the difference between the Area (% of total land area) of Estonia and Area (% of total land area) of Trinidad and Tobago?
Ensure brevity in your answer.  10.18. In the year 1994, what is the difference between the Area (% of total land area) in Estonia and Area (% of total land area) in Zambia?
Provide a short and direct response. -2.91. In the year 1994, what is the difference between the Area (% of total land area) in Oman and Area (% of total land area) in Trinidad and Tobago?
Ensure brevity in your answer.  -12.33. In the year 1994, what is the difference between the Area (% of total land area) in Oman and Area (% of total land area) in Zambia?
Provide a short and direct response. -25.42. In the year 1994, what is the difference between the Area (% of total land area) in Trinidad and Tobago and Area (% of total land area) in Zambia?
Keep it short and to the point. -13.1. In the year 1995, what is the difference between the Area (% of total land area) in Estonia and Area (% of total land area) in Oman?
Give a very brief answer. 19.92. In the year 1995, what is the difference between the Area (% of total land area) in Estonia and Area (% of total land area) in Trinidad and Tobago?
Provide a succinct answer. 8.56. In the year 1995, what is the difference between the Area (% of total land area) in Estonia and Area (% of total land area) in Zambia?
Keep it short and to the point. -5.49. In the year 1995, what is the difference between the Area (% of total land area) in Oman and Area (% of total land area) in Trinidad and Tobago?
Give a very brief answer. -11.35. In the year 1995, what is the difference between the Area (% of total land area) of Oman and Area (% of total land area) of Zambia?
Your response must be concise. -25.4. In the year 1995, what is the difference between the Area (% of total land area) of Trinidad and Tobago and Area (% of total land area) of Zambia?
Offer a very short reply. -14.05. In the year 1996, what is the difference between the Area (% of total land area) in Estonia and Area (% of total land area) in Oman?
Keep it short and to the point. 20.25. In the year 1996, what is the difference between the Area (% of total land area) of Estonia and Area (% of total land area) of Trinidad and Tobago?
Give a very brief answer. 8.89. In the year 1996, what is the difference between the Area (% of total land area) of Estonia and Area (% of total land area) of Zambia?
Your response must be concise. -5.7. In the year 1996, what is the difference between the Area (% of total land area) of Oman and Area (% of total land area) of Trinidad and Tobago?
Provide a short and direct response. -11.35. In the year 1996, what is the difference between the Area (% of total land area) in Oman and Area (% of total land area) in Zambia?
Your response must be concise. -25.95. In the year 1996, what is the difference between the Area (% of total land area) of Trinidad and Tobago and Area (% of total land area) of Zambia?
Make the answer very short. -14.6. In the year 1997, what is the difference between the Area (% of total land area) of Estonia and Area (% of total land area) of Oman?
Give a very brief answer. 20.68. In the year 1997, what is the difference between the Area (% of total land area) of Estonia and Area (% of total land area) of Trinidad and Tobago?
Offer a very short reply. 10.29. In the year 1997, what is the difference between the Area (% of total land area) of Estonia and Area (% of total land area) of Zambia?
Keep it short and to the point. -5.42. In the year 1997, what is the difference between the Area (% of total land area) in Oman and Area (% of total land area) in Trinidad and Tobago?
Ensure brevity in your answer.  -10.38. In the year 1997, what is the difference between the Area (% of total land area) in Oman and Area (% of total land area) in Zambia?
Ensure brevity in your answer.  -26.1. In the year 1997, what is the difference between the Area (% of total land area) of Trinidad and Tobago and Area (% of total land area) of Zambia?
Offer a terse response. -15.71. In the year 1998, what is the difference between the Area (% of total land area) of Estonia and Area (% of total land area) of Oman?
Provide a succinct answer. 21.14. In the year 1998, what is the difference between the Area (% of total land area) in Estonia and Area (% of total land area) in Trinidad and Tobago?
Keep it short and to the point. 11.74. In the year 1998, what is the difference between the Area (% of total land area) of Estonia and Area (% of total land area) of Zambia?
Give a very brief answer. -5.02. In the year 1998, what is the difference between the Area (% of total land area) in Oman and Area (% of total land area) in Trinidad and Tobago?
Your response must be concise. -9.41. In the year 1998, what is the difference between the Area (% of total land area) in Oman and Area (% of total land area) in Zambia?
Give a very brief answer. -26.17. In the year 1998, what is the difference between the Area (% of total land area) of Trinidad and Tobago and Area (% of total land area) of Zambia?
Make the answer very short. -16.76. What is the ratio of the Area (% of total land area) in Estonia in 1992 to that in 1993?
Offer a very short reply. 1.04. What is the ratio of the Area (% of total land area) in Oman in 1992 to that in 1993?
Make the answer very short. 1.01. What is the ratio of the Area (% of total land area) in Zambia in 1992 to that in 1993?
Keep it short and to the point. 0.99. What is the ratio of the Area (% of total land area) of Estonia in 1992 to that in 1994?
Provide a succinct answer. 1.25. What is the ratio of the Area (% of total land area) of Oman in 1992 to that in 1994?
Your response must be concise. 1.01. What is the ratio of the Area (% of total land area) of Trinidad and Tobago in 1992 to that in 1994?
Your answer should be very brief. 1. What is the ratio of the Area (% of total land area) in Zambia in 1992 to that in 1994?
Give a very brief answer. 0.98. What is the ratio of the Area (% of total land area) in Estonia in 1992 to that in 1995?
Give a very brief answer. 1.39. What is the ratio of the Area (% of total land area) of Oman in 1992 to that in 1995?
Provide a succinct answer. 1.01. What is the ratio of the Area (% of total land area) of Trinidad and Tobago in 1992 to that in 1995?
Offer a very short reply. 1.07. What is the ratio of the Area (% of total land area) of Zambia in 1992 to that in 1995?
Your response must be concise. 0.98. What is the ratio of the Area (% of total land area) in Estonia in 1992 to that in 1996?
Offer a terse response. 1.37. What is the ratio of the Area (% of total land area) in Oman in 1992 to that in 1996?
Your answer should be compact. 1.01. What is the ratio of the Area (% of total land area) of Trinidad and Tobago in 1992 to that in 1996?
Give a very brief answer. 1.07. What is the ratio of the Area (% of total land area) in Zambia in 1992 to that in 1996?
Your response must be concise. 0.96. What is the ratio of the Area (% of total land area) of Estonia in 1992 to that in 1997?
Give a very brief answer. 1.34. What is the ratio of the Area (% of total land area) of Oman in 1992 to that in 1997?
Ensure brevity in your answer.  1.01. What is the ratio of the Area (% of total land area) of Trinidad and Tobago in 1992 to that in 1997?
Keep it short and to the point. 1.14. What is the ratio of the Area (% of total land area) in Zambia in 1992 to that in 1997?
Ensure brevity in your answer.  0.96. What is the ratio of the Area (% of total land area) of Estonia in 1992 to that in 1998?
Give a very brief answer. 1.32. What is the ratio of the Area (% of total land area) in Oman in 1992 to that in 1998?
Your response must be concise. 1.01. What is the ratio of the Area (% of total land area) in Trinidad and Tobago in 1992 to that in 1998?
Your response must be concise. 1.23. What is the ratio of the Area (% of total land area) in Zambia in 1992 to that in 1998?
Ensure brevity in your answer.  0.96. What is the ratio of the Area (% of total land area) in Estonia in 1993 to that in 1994?
Keep it short and to the point. 1.2. What is the ratio of the Area (% of total land area) of Oman in 1993 to that in 1994?
Your answer should be very brief. 1. What is the ratio of the Area (% of total land area) in Trinidad and Tobago in 1993 to that in 1994?
Ensure brevity in your answer.  1. What is the ratio of the Area (% of total land area) in Zambia in 1993 to that in 1994?
Ensure brevity in your answer.  0.99. What is the ratio of the Area (% of total land area) in Estonia in 1993 to that in 1995?
Ensure brevity in your answer.  1.33. What is the ratio of the Area (% of total land area) of Trinidad and Tobago in 1993 to that in 1995?
Your answer should be compact. 1.07. What is the ratio of the Area (% of total land area) in Zambia in 1993 to that in 1995?
Make the answer very short. 0.99. What is the ratio of the Area (% of total land area) of Estonia in 1993 to that in 1996?
Ensure brevity in your answer.  1.31. What is the ratio of the Area (% of total land area) of Oman in 1993 to that in 1996?
Your answer should be compact. 1. What is the ratio of the Area (% of total land area) of Trinidad and Tobago in 1993 to that in 1996?
Make the answer very short. 1.07. What is the ratio of the Area (% of total land area) of Zambia in 1993 to that in 1996?
Give a very brief answer. 0.97. What is the ratio of the Area (% of total land area) of Estonia in 1993 to that in 1997?
Keep it short and to the point. 1.29. What is the ratio of the Area (% of total land area) of Trinidad and Tobago in 1993 to that in 1997?
Your response must be concise. 1.14. What is the ratio of the Area (% of total land area) in Estonia in 1993 to that in 1998?
Ensure brevity in your answer.  1.27. What is the ratio of the Area (% of total land area) in Oman in 1993 to that in 1998?
Provide a short and direct response. 1. What is the ratio of the Area (% of total land area) of Trinidad and Tobago in 1993 to that in 1998?
Provide a succinct answer. 1.23. What is the ratio of the Area (% of total land area) of Zambia in 1993 to that in 1998?
Offer a terse response. 0.96. What is the ratio of the Area (% of total land area) of Estonia in 1994 to that in 1995?
Offer a terse response. 1.11. What is the ratio of the Area (% of total land area) in Trinidad and Tobago in 1994 to that in 1995?
Keep it short and to the point. 1.07. What is the ratio of the Area (% of total land area) in Zambia in 1994 to that in 1995?
Provide a short and direct response. 1. What is the ratio of the Area (% of total land area) in Estonia in 1994 to that in 1996?
Keep it short and to the point. 1.1. What is the ratio of the Area (% of total land area) of Trinidad and Tobago in 1994 to that in 1996?
Offer a very short reply. 1.07. What is the ratio of the Area (% of total land area) of Zambia in 1994 to that in 1996?
Provide a short and direct response. 0.98. What is the ratio of the Area (% of total land area) of Estonia in 1994 to that in 1997?
Provide a short and direct response. 1.08. What is the ratio of the Area (% of total land area) of Trinidad and Tobago in 1994 to that in 1997?
Your response must be concise. 1.14. What is the ratio of the Area (% of total land area) of Zambia in 1994 to that in 1997?
Your answer should be compact. 0.98. What is the ratio of the Area (% of total land area) of Estonia in 1994 to that in 1998?
Make the answer very short. 1.06. What is the ratio of the Area (% of total land area) of Trinidad and Tobago in 1994 to that in 1998?
Your answer should be compact. 1.23. What is the ratio of the Area (% of total land area) of Zambia in 1994 to that in 1998?
Offer a very short reply. 0.97. What is the ratio of the Area (% of total land area) in Estonia in 1995 to that in 1996?
Provide a succinct answer. 0.99. What is the ratio of the Area (% of total land area) of Oman in 1995 to that in 1996?
Keep it short and to the point. 1. What is the ratio of the Area (% of total land area) of Zambia in 1995 to that in 1996?
Ensure brevity in your answer.  0.98. What is the ratio of the Area (% of total land area) of Estonia in 1995 to that in 1997?
Make the answer very short. 0.97. What is the ratio of the Area (% of total land area) in Oman in 1995 to that in 1997?
Give a very brief answer. 1. What is the ratio of the Area (% of total land area) of Trinidad and Tobago in 1995 to that in 1997?
Give a very brief answer. 1.07. What is the ratio of the Area (% of total land area) in Zambia in 1995 to that in 1997?
Provide a short and direct response. 0.98. What is the ratio of the Area (% of total land area) of Estonia in 1995 to that in 1998?
Your answer should be compact. 0.95. What is the ratio of the Area (% of total land area) of Trinidad and Tobago in 1995 to that in 1998?
Make the answer very short. 1.15. What is the ratio of the Area (% of total land area) of Zambia in 1995 to that in 1998?
Offer a very short reply. 0.97. What is the ratio of the Area (% of total land area) of Estonia in 1996 to that in 1997?
Make the answer very short. 0.98. What is the ratio of the Area (% of total land area) of Trinidad and Tobago in 1996 to that in 1997?
Your answer should be very brief. 1.07. What is the ratio of the Area (% of total land area) in Zambia in 1996 to that in 1997?
Offer a very short reply. 1. What is the ratio of the Area (% of total land area) of Estonia in 1996 to that in 1998?
Make the answer very short. 0.96. What is the ratio of the Area (% of total land area) in Trinidad and Tobago in 1996 to that in 1998?
Give a very brief answer. 1.15. What is the ratio of the Area (% of total land area) in Estonia in 1997 to that in 1998?
Your response must be concise. 0.98. What is the ratio of the Area (% of total land area) of Trinidad and Tobago in 1997 to that in 1998?
Offer a terse response. 1.08. What is the difference between the highest and the second highest Area (% of total land area) of Estonia?
Offer a terse response. 1.27. What is the difference between the highest and the second highest Area (% of total land area) in Oman?
Your answer should be compact. 0.04. What is the difference between the highest and the second highest Area (% of total land area) in Zambia?
Make the answer very short. 0.07. What is the difference between the highest and the lowest Area (% of total land area) of Estonia?
Provide a short and direct response. 9.04. What is the difference between the highest and the lowest Area (% of total land area) of Oman?
Ensure brevity in your answer.  0.04. What is the difference between the highest and the lowest Area (% of total land area) of Trinidad and Tobago?
Offer a terse response. 2.92. What is the difference between the highest and the lowest Area (% of total land area) of Zambia?
Provide a succinct answer. 1.29. 